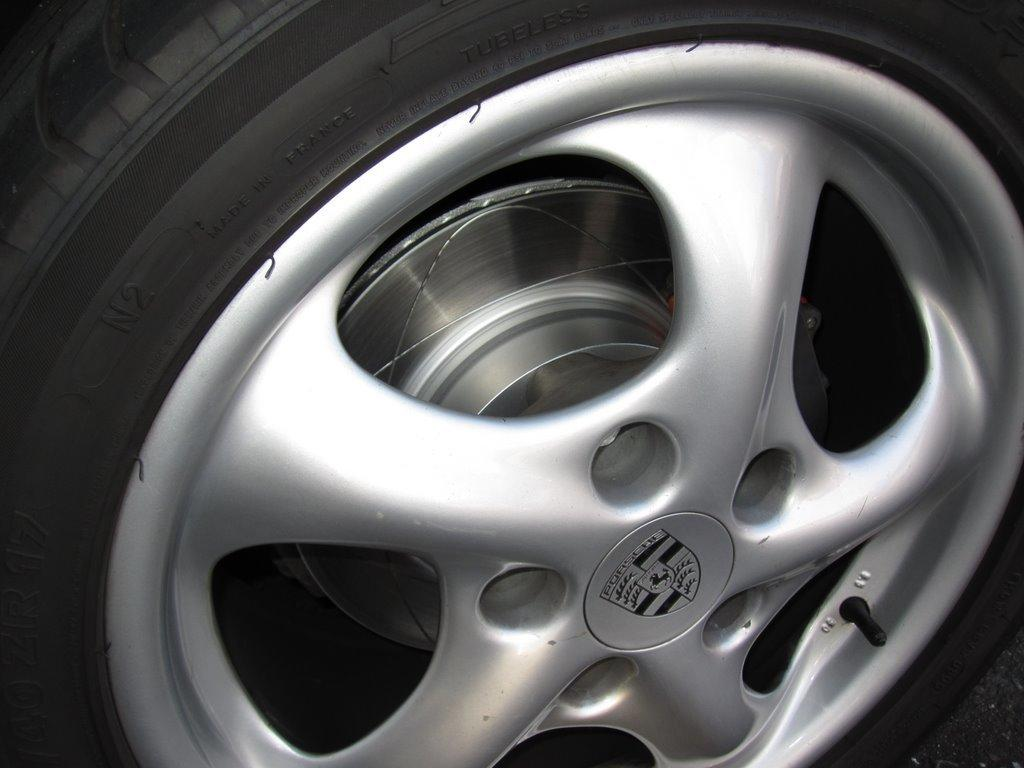What is the main subject of the image? The main subject of the image is a Tyre. Can you describe any specific features of the Tyre? Yes, the Tyre has a logo on it. What type of noise does the Tyre make in the image? The image is static, so there is no noise present. Who is the owner of the Tyre in the image? The image does not provide any information about the owner of the Tyre. Can you see any magical elements associated with the Tyre in the image? There are no magical elements present in the image. 